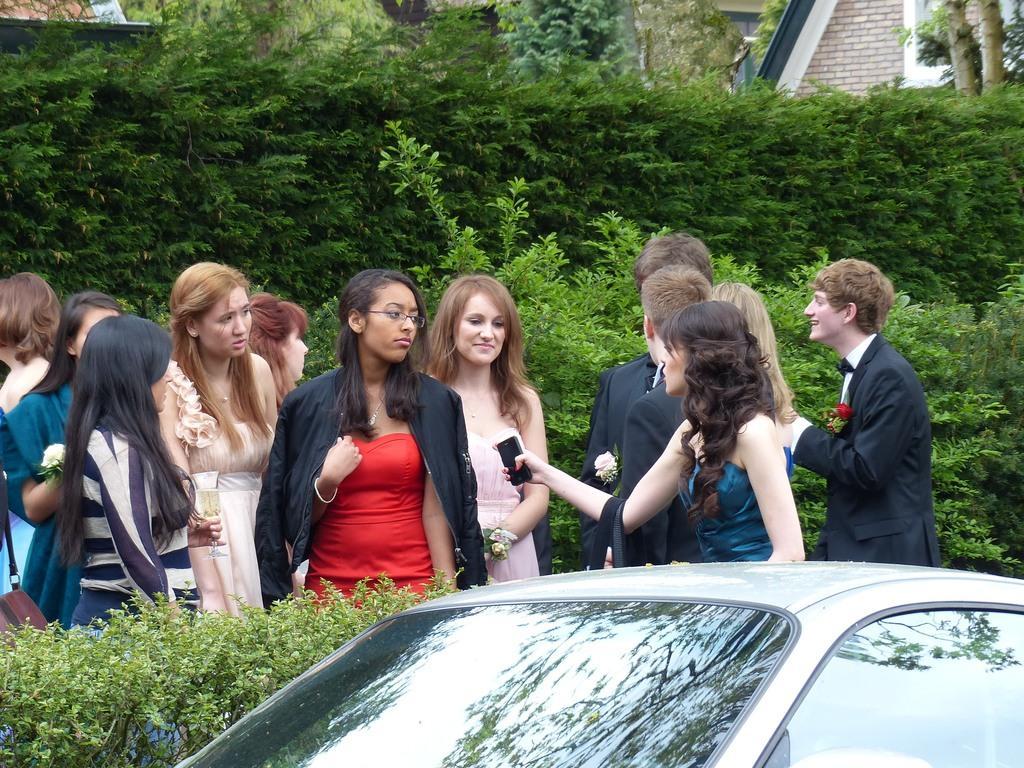Could you give a brief overview of what you see in this image? In this image we can see there are people standing and holding a cell phone and glass. In front of them there is a car. At the back there are trees and house. 